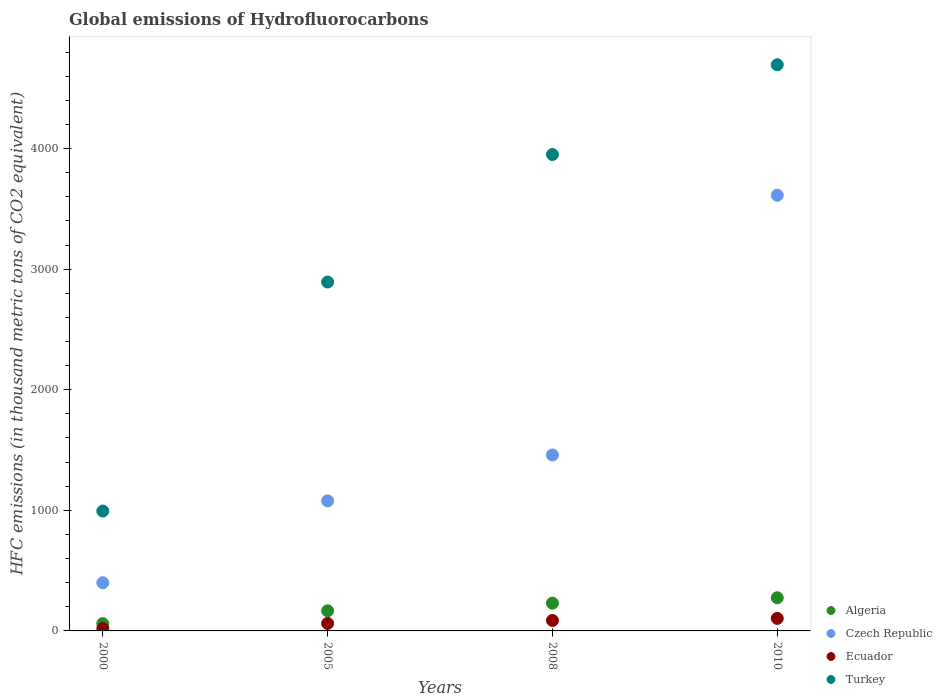How many different coloured dotlines are there?
Provide a succinct answer. 4. What is the global emissions of Hydrofluorocarbons in Algeria in 2000?
Provide a short and direct response. 60.5. Across all years, what is the maximum global emissions of Hydrofluorocarbons in Czech Republic?
Make the answer very short. 3613. Across all years, what is the minimum global emissions of Hydrofluorocarbons in Algeria?
Make the answer very short. 60.5. In which year was the global emissions of Hydrofluorocarbons in Ecuador maximum?
Your answer should be very brief. 2010. What is the total global emissions of Hydrofluorocarbons in Czech Republic in the graph?
Your answer should be compact. 6550.2. What is the difference between the global emissions of Hydrofluorocarbons in Algeria in 2005 and that in 2010?
Offer a terse response. -108.2. What is the difference between the global emissions of Hydrofluorocarbons in Turkey in 2000 and the global emissions of Hydrofluorocarbons in Algeria in 2005?
Your answer should be very brief. 827.6. What is the average global emissions of Hydrofluorocarbons in Ecuador per year?
Ensure brevity in your answer.  68.15. In the year 2008, what is the difference between the global emissions of Hydrofluorocarbons in Czech Republic and global emissions of Hydrofluorocarbons in Algeria?
Provide a succinct answer. 1228.8. In how many years, is the global emissions of Hydrofluorocarbons in Turkey greater than 2000 thousand metric tons?
Make the answer very short. 3. What is the ratio of the global emissions of Hydrofluorocarbons in Turkey in 2000 to that in 2008?
Keep it short and to the point. 0.25. Is the global emissions of Hydrofluorocarbons in Algeria in 2005 less than that in 2010?
Offer a very short reply. Yes. Is the difference between the global emissions of Hydrofluorocarbons in Czech Republic in 2005 and 2010 greater than the difference between the global emissions of Hydrofluorocarbons in Algeria in 2005 and 2010?
Your answer should be very brief. No. What is the difference between the highest and the second highest global emissions of Hydrofluorocarbons in Czech Republic?
Your response must be concise. 2154. What is the difference between the highest and the lowest global emissions of Hydrofluorocarbons in Czech Republic?
Your answer should be compact. 3213.5. In how many years, is the global emissions of Hydrofluorocarbons in Algeria greater than the average global emissions of Hydrofluorocarbons in Algeria taken over all years?
Your response must be concise. 2. Is the sum of the global emissions of Hydrofluorocarbons in Turkey in 2005 and 2010 greater than the maximum global emissions of Hydrofluorocarbons in Algeria across all years?
Give a very brief answer. Yes. Is it the case that in every year, the sum of the global emissions of Hydrofluorocarbons in Turkey and global emissions of Hydrofluorocarbons in Algeria  is greater than the sum of global emissions of Hydrofluorocarbons in Czech Republic and global emissions of Hydrofluorocarbons in Ecuador?
Keep it short and to the point. Yes. Is it the case that in every year, the sum of the global emissions of Hydrofluorocarbons in Turkey and global emissions of Hydrofluorocarbons in Czech Republic  is greater than the global emissions of Hydrofluorocarbons in Algeria?
Your answer should be compact. Yes. Does the global emissions of Hydrofluorocarbons in Czech Republic monotonically increase over the years?
Offer a terse response. Yes. How many dotlines are there?
Keep it short and to the point. 4. How many years are there in the graph?
Your response must be concise. 4. Does the graph contain any zero values?
Give a very brief answer. No. How are the legend labels stacked?
Provide a short and direct response. Vertical. What is the title of the graph?
Your response must be concise. Global emissions of Hydrofluorocarbons. What is the label or title of the X-axis?
Offer a terse response. Years. What is the label or title of the Y-axis?
Offer a very short reply. HFC emissions (in thousand metric tons of CO2 equivalent). What is the HFC emissions (in thousand metric tons of CO2 equivalent) of Algeria in 2000?
Your answer should be very brief. 60.5. What is the HFC emissions (in thousand metric tons of CO2 equivalent) in Czech Republic in 2000?
Make the answer very short. 399.5. What is the HFC emissions (in thousand metric tons of CO2 equivalent) in Turkey in 2000?
Ensure brevity in your answer.  994.4. What is the HFC emissions (in thousand metric tons of CO2 equivalent) in Algeria in 2005?
Provide a short and direct response. 166.8. What is the HFC emissions (in thousand metric tons of CO2 equivalent) of Czech Republic in 2005?
Give a very brief answer. 1078.7. What is the HFC emissions (in thousand metric tons of CO2 equivalent) of Ecuador in 2005?
Make the answer very short. 62.2. What is the HFC emissions (in thousand metric tons of CO2 equivalent) in Turkey in 2005?
Your answer should be compact. 2893.2. What is the HFC emissions (in thousand metric tons of CO2 equivalent) of Algeria in 2008?
Offer a terse response. 230.2. What is the HFC emissions (in thousand metric tons of CO2 equivalent) of Czech Republic in 2008?
Offer a very short reply. 1459. What is the HFC emissions (in thousand metric tons of CO2 equivalent) in Ecuador in 2008?
Make the answer very short. 86.7. What is the HFC emissions (in thousand metric tons of CO2 equivalent) in Turkey in 2008?
Your answer should be very brief. 3950.8. What is the HFC emissions (in thousand metric tons of CO2 equivalent) in Algeria in 2010?
Your answer should be compact. 275. What is the HFC emissions (in thousand metric tons of CO2 equivalent) in Czech Republic in 2010?
Keep it short and to the point. 3613. What is the HFC emissions (in thousand metric tons of CO2 equivalent) of Ecuador in 2010?
Provide a succinct answer. 104. What is the HFC emissions (in thousand metric tons of CO2 equivalent) of Turkey in 2010?
Provide a short and direct response. 4695. Across all years, what is the maximum HFC emissions (in thousand metric tons of CO2 equivalent) of Algeria?
Offer a very short reply. 275. Across all years, what is the maximum HFC emissions (in thousand metric tons of CO2 equivalent) in Czech Republic?
Offer a very short reply. 3613. Across all years, what is the maximum HFC emissions (in thousand metric tons of CO2 equivalent) in Ecuador?
Make the answer very short. 104. Across all years, what is the maximum HFC emissions (in thousand metric tons of CO2 equivalent) of Turkey?
Your response must be concise. 4695. Across all years, what is the minimum HFC emissions (in thousand metric tons of CO2 equivalent) in Algeria?
Offer a very short reply. 60.5. Across all years, what is the minimum HFC emissions (in thousand metric tons of CO2 equivalent) in Czech Republic?
Provide a short and direct response. 399.5. Across all years, what is the minimum HFC emissions (in thousand metric tons of CO2 equivalent) in Ecuador?
Offer a terse response. 19.7. Across all years, what is the minimum HFC emissions (in thousand metric tons of CO2 equivalent) in Turkey?
Offer a terse response. 994.4. What is the total HFC emissions (in thousand metric tons of CO2 equivalent) in Algeria in the graph?
Your response must be concise. 732.5. What is the total HFC emissions (in thousand metric tons of CO2 equivalent) of Czech Republic in the graph?
Provide a short and direct response. 6550.2. What is the total HFC emissions (in thousand metric tons of CO2 equivalent) of Ecuador in the graph?
Provide a short and direct response. 272.6. What is the total HFC emissions (in thousand metric tons of CO2 equivalent) of Turkey in the graph?
Provide a short and direct response. 1.25e+04. What is the difference between the HFC emissions (in thousand metric tons of CO2 equivalent) in Algeria in 2000 and that in 2005?
Offer a very short reply. -106.3. What is the difference between the HFC emissions (in thousand metric tons of CO2 equivalent) of Czech Republic in 2000 and that in 2005?
Your response must be concise. -679.2. What is the difference between the HFC emissions (in thousand metric tons of CO2 equivalent) in Ecuador in 2000 and that in 2005?
Provide a short and direct response. -42.5. What is the difference between the HFC emissions (in thousand metric tons of CO2 equivalent) of Turkey in 2000 and that in 2005?
Ensure brevity in your answer.  -1898.8. What is the difference between the HFC emissions (in thousand metric tons of CO2 equivalent) in Algeria in 2000 and that in 2008?
Your response must be concise. -169.7. What is the difference between the HFC emissions (in thousand metric tons of CO2 equivalent) of Czech Republic in 2000 and that in 2008?
Provide a succinct answer. -1059.5. What is the difference between the HFC emissions (in thousand metric tons of CO2 equivalent) in Ecuador in 2000 and that in 2008?
Keep it short and to the point. -67. What is the difference between the HFC emissions (in thousand metric tons of CO2 equivalent) in Turkey in 2000 and that in 2008?
Ensure brevity in your answer.  -2956.4. What is the difference between the HFC emissions (in thousand metric tons of CO2 equivalent) in Algeria in 2000 and that in 2010?
Make the answer very short. -214.5. What is the difference between the HFC emissions (in thousand metric tons of CO2 equivalent) in Czech Republic in 2000 and that in 2010?
Make the answer very short. -3213.5. What is the difference between the HFC emissions (in thousand metric tons of CO2 equivalent) in Ecuador in 2000 and that in 2010?
Offer a very short reply. -84.3. What is the difference between the HFC emissions (in thousand metric tons of CO2 equivalent) of Turkey in 2000 and that in 2010?
Keep it short and to the point. -3700.6. What is the difference between the HFC emissions (in thousand metric tons of CO2 equivalent) of Algeria in 2005 and that in 2008?
Make the answer very short. -63.4. What is the difference between the HFC emissions (in thousand metric tons of CO2 equivalent) in Czech Republic in 2005 and that in 2008?
Provide a short and direct response. -380.3. What is the difference between the HFC emissions (in thousand metric tons of CO2 equivalent) of Ecuador in 2005 and that in 2008?
Offer a very short reply. -24.5. What is the difference between the HFC emissions (in thousand metric tons of CO2 equivalent) in Turkey in 2005 and that in 2008?
Give a very brief answer. -1057.6. What is the difference between the HFC emissions (in thousand metric tons of CO2 equivalent) in Algeria in 2005 and that in 2010?
Give a very brief answer. -108.2. What is the difference between the HFC emissions (in thousand metric tons of CO2 equivalent) in Czech Republic in 2005 and that in 2010?
Your answer should be very brief. -2534.3. What is the difference between the HFC emissions (in thousand metric tons of CO2 equivalent) of Ecuador in 2005 and that in 2010?
Offer a very short reply. -41.8. What is the difference between the HFC emissions (in thousand metric tons of CO2 equivalent) in Turkey in 2005 and that in 2010?
Offer a terse response. -1801.8. What is the difference between the HFC emissions (in thousand metric tons of CO2 equivalent) of Algeria in 2008 and that in 2010?
Your answer should be very brief. -44.8. What is the difference between the HFC emissions (in thousand metric tons of CO2 equivalent) in Czech Republic in 2008 and that in 2010?
Your answer should be very brief. -2154. What is the difference between the HFC emissions (in thousand metric tons of CO2 equivalent) of Ecuador in 2008 and that in 2010?
Provide a succinct answer. -17.3. What is the difference between the HFC emissions (in thousand metric tons of CO2 equivalent) of Turkey in 2008 and that in 2010?
Keep it short and to the point. -744.2. What is the difference between the HFC emissions (in thousand metric tons of CO2 equivalent) in Algeria in 2000 and the HFC emissions (in thousand metric tons of CO2 equivalent) in Czech Republic in 2005?
Provide a succinct answer. -1018.2. What is the difference between the HFC emissions (in thousand metric tons of CO2 equivalent) of Algeria in 2000 and the HFC emissions (in thousand metric tons of CO2 equivalent) of Turkey in 2005?
Ensure brevity in your answer.  -2832.7. What is the difference between the HFC emissions (in thousand metric tons of CO2 equivalent) in Czech Republic in 2000 and the HFC emissions (in thousand metric tons of CO2 equivalent) in Ecuador in 2005?
Offer a very short reply. 337.3. What is the difference between the HFC emissions (in thousand metric tons of CO2 equivalent) in Czech Republic in 2000 and the HFC emissions (in thousand metric tons of CO2 equivalent) in Turkey in 2005?
Provide a succinct answer. -2493.7. What is the difference between the HFC emissions (in thousand metric tons of CO2 equivalent) of Ecuador in 2000 and the HFC emissions (in thousand metric tons of CO2 equivalent) of Turkey in 2005?
Your answer should be very brief. -2873.5. What is the difference between the HFC emissions (in thousand metric tons of CO2 equivalent) in Algeria in 2000 and the HFC emissions (in thousand metric tons of CO2 equivalent) in Czech Republic in 2008?
Your response must be concise. -1398.5. What is the difference between the HFC emissions (in thousand metric tons of CO2 equivalent) of Algeria in 2000 and the HFC emissions (in thousand metric tons of CO2 equivalent) of Ecuador in 2008?
Ensure brevity in your answer.  -26.2. What is the difference between the HFC emissions (in thousand metric tons of CO2 equivalent) of Algeria in 2000 and the HFC emissions (in thousand metric tons of CO2 equivalent) of Turkey in 2008?
Give a very brief answer. -3890.3. What is the difference between the HFC emissions (in thousand metric tons of CO2 equivalent) in Czech Republic in 2000 and the HFC emissions (in thousand metric tons of CO2 equivalent) in Ecuador in 2008?
Ensure brevity in your answer.  312.8. What is the difference between the HFC emissions (in thousand metric tons of CO2 equivalent) of Czech Republic in 2000 and the HFC emissions (in thousand metric tons of CO2 equivalent) of Turkey in 2008?
Offer a terse response. -3551.3. What is the difference between the HFC emissions (in thousand metric tons of CO2 equivalent) in Ecuador in 2000 and the HFC emissions (in thousand metric tons of CO2 equivalent) in Turkey in 2008?
Offer a terse response. -3931.1. What is the difference between the HFC emissions (in thousand metric tons of CO2 equivalent) in Algeria in 2000 and the HFC emissions (in thousand metric tons of CO2 equivalent) in Czech Republic in 2010?
Your answer should be compact. -3552.5. What is the difference between the HFC emissions (in thousand metric tons of CO2 equivalent) of Algeria in 2000 and the HFC emissions (in thousand metric tons of CO2 equivalent) of Ecuador in 2010?
Ensure brevity in your answer.  -43.5. What is the difference between the HFC emissions (in thousand metric tons of CO2 equivalent) of Algeria in 2000 and the HFC emissions (in thousand metric tons of CO2 equivalent) of Turkey in 2010?
Your response must be concise. -4634.5. What is the difference between the HFC emissions (in thousand metric tons of CO2 equivalent) in Czech Republic in 2000 and the HFC emissions (in thousand metric tons of CO2 equivalent) in Ecuador in 2010?
Provide a succinct answer. 295.5. What is the difference between the HFC emissions (in thousand metric tons of CO2 equivalent) of Czech Republic in 2000 and the HFC emissions (in thousand metric tons of CO2 equivalent) of Turkey in 2010?
Make the answer very short. -4295.5. What is the difference between the HFC emissions (in thousand metric tons of CO2 equivalent) of Ecuador in 2000 and the HFC emissions (in thousand metric tons of CO2 equivalent) of Turkey in 2010?
Your answer should be compact. -4675.3. What is the difference between the HFC emissions (in thousand metric tons of CO2 equivalent) of Algeria in 2005 and the HFC emissions (in thousand metric tons of CO2 equivalent) of Czech Republic in 2008?
Make the answer very short. -1292.2. What is the difference between the HFC emissions (in thousand metric tons of CO2 equivalent) of Algeria in 2005 and the HFC emissions (in thousand metric tons of CO2 equivalent) of Ecuador in 2008?
Your response must be concise. 80.1. What is the difference between the HFC emissions (in thousand metric tons of CO2 equivalent) of Algeria in 2005 and the HFC emissions (in thousand metric tons of CO2 equivalent) of Turkey in 2008?
Your response must be concise. -3784. What is the difference between the HFC emissions (in thousand metric tons of CO2 equivalent) of Czech Republic in 2005 and the HFC emissions (in thousand metric tons of CO2 equivalent) of Ecuador in 2008?
Give a very brief answer. 992. What is the difference between the HFC emissions (in thousand metric tons of CO2 equivalent) in Czech Republic in 2005 and the HFC emissions (in thousand metric tons of CO2 equivalent) in Turkey in 2008?
Your answer should be compact. -2872.1. What is the difference between the HFC emissions (in thousand metric tons of CO2 equivalent) in Ecuador in 2005 and the HFC emissions (in thousand metric tons of CO2 equivalent) in Turkey in 2008?
Ensure brevity in your answer.  -3888.6. What is the difference between the HFC emissions (in thousand metric tons of CO2 equivalent) of Algeria in 2005 and the HFC emissions (in thousand metric tons of CO2 equivalent) of Czech Republic in 2010?
Provide a succinct answer. -3446.2. What is the difference between the HFC emissions (in thousand metric tons of CO2 equivalent) in Algeria in 2005 and the HFC emissions (in thousand metric tons of CO2 equivalent) in Ecuador in 2010?
Your answer should be compact. 62.8. What is the difference between the HFC emissions (in thousand metric tons of CO2 equivalent) of Algeria in 2005 and the HFC emissions (in thousand metric tons of CO2 equivalent) of Turkey in 2010?
Your response must be concise. -4528.2. What is the difference between the HFC emissions (in thousand metric tons of CO2 equivalent) of Czech Republic in 2005 and the HFC emissions (in thousand metric tons of CO2 equivalent) of Ecuador in 2010?
Provide a short and direct response. 974.7. What is the difference between the HFC emissions (in thousand metric tons of CO2 equivalent) in Czech Republic in 2005 and the HFC emissions (in thousand metric tons of CO2 equivalent) in Turkey in 2010?
Provide a short and direct response. -3616.3. What is the difference between the HFC emissions (in thousand metric tons of CO2 equivalent) in Ecuador in 2005 and the HFC emissions (in thousand metric tons of CO2 equivalent) in Turkey in 2010?
Offer a terse response. -4632.8. What is the difference between the HFC emissions (in thousand metric tons of CO2 equivalent) in Algeria in 2008 and the HFC emissions (in thousand metric tons of CO2 equivalent) in Czech Republic in 2010?
Your answer should be very brief. -3382.8. What is the difference between the HFC emissions (in thousand metric tons of CO2 equivalent) of Algeria in 2008 and the HFC emissions (in thousand metric tons of CO2 equivalent) of Ecuador in 2010?
Make the answer very short. 126.2. What is the difference between the HFC emissions (in thousand metric tons of CO2 equivalent) of Algeria in 2008 and the HFC emissions (in thousand metric tons of CO2 equivalent) of Turkey in 2010?
Your response must be concise. -4464.8. What is the difference between the HFC emissions (in thousand metric tons of CO2 equivalent) in Czech Republic in 2008 and the HFC emissions (in thousand metric tons of CO2 equivalent) in Ecuador in 2010?
Your answer should be compact. 1355. What is the difference between the HFC emissions (in thousand metric tons of CO2 equivalent) of Czech Republic in 2008 and the HFC emissions (in thousand metric tons of CO2 equivalent) of Turkey in 2010?
Your answer should be very brief. -3236. What is the difference between the HFC emissions (in thousand metric tons of CO2 equivalent) in Ecuador in 2008 and the HFC emissions (in thousand metric tons of CO2 equivalent) in Turkey in 2010?
Ensure brevity in your answer.  -4608.3. What is the average HFC emissions (in thousand metric tons of CO2 equivalent) of Algeria per year?
Offer a terse response. 183.12. What is the average HFC emissions (in thousand metric tons of CO2 equivalent) in Czech Republic per year?
Your answer should be compact. 1637.55. What is the average HFC emissions (in thousand metric tons of CO2 equivalent) of Ecuador per year?
Offer a very short reply. 68.15. What is the average HFC emissions (in thousand metric tons of CO2 equivalent) in Turkey per year?
Give a very brief answer. 3133.35. In the year 2000, what is the difference between the HFC emissions (in thousand metric tons of CO2 equivalent) of Algeria and HFC emissions (in thousand metric tons of CO2 equivalent) of Czech Republic?
Your answer should be very brief. -339. In the year 2000, what is the difference between the HFC emissions (in thousand metric tons of CO2 equivalent) in Algeria and HFC emissions (in thousand metric tons of CO2 equivalent) in Ecuador?
Offer a very short reply. 40.8. In the year 2000, what is the difference between the HFC emissions (in thousand metric tons of CO2 equivalent) in Algeria and HFC emissions (in thousand metric tons of CO2 equivalent) in Turkey?
Your answer should be very brief. -933.9. In the year 2000, what is the difference between the HFC emissions (in thousand metric tons of CO2 equivalent) in Czech Republic and HFC emissions (in thousand metric tons of CO2 equivalent) in Ecuador?
Your response must be concise. 379.8. In the year 2000, what is the difference between the HFC emissions (in thousand metric tons of CO2 equivalent) in Czech Republic and HFC emissions (in thousand metric tons of CO2 equivalent) in Turkey?
Offer a terse response. -594.9. In the year 2000, what is the difference between the HFC emissions (in thousand metric tons of CO2 equivalent) in Ecuador and HFC emissions (in thousand metric tons of CO2 equivalent) in Turkey?
Ensure brevity in your answer.  -974.7. In the year 2005, what is the difference between the HFC emissions (in thousand metric tons of CO2 equivalent) of Algeria and HFC emissions (in thousand metric tons of CO2 equivalent) of Czech Republic?
Give a very brief answer. -911.9. In the year 2005, what is the difference between the HFC emissions (in thousand metric tons of CO2 equivalent) in Algeria and HFC emissions (in thousand metric tons of CO2 equivalent) in Ecuador?
Make the answer very short. 104.6. In the year 2005, what is the difference between the HFC emissions (in thousand metric tons of CO2 equivalent) of Algeria and HFC emissions (in thousand metric tons of CO2 equivalent) of Turkey?
Offer a terse response. -2726.4. In the year 2005, what is the difference between the HFC emissions (in thousand metric tons of CO2 equivalent) of Czech Republic and HFC emissions (in thousand metric tons of CO2 equivalent) of Ecuador?
Your answer should be compact. 1016.5. In the year 2005, what is the difference between the HFC emissions (in thousand metric tons of CO2 equivalent) of Czech Republic and HFC emissions (in thousand metric tons of CO2 equivalent) of Turkey?
Give a very brief answer. -1814.5. In the year 2005, what is the difference between the HFC emissions (in thousand metric tons of CO2 equivalent) in Ecuador and HFC emissions (in thousand metric tons of CO2 equivalent) in Turkey?
Make the answer very short. -2831. In the year 2008, what is the difference between the HFC emissions (in thousand metric tons of CO2 equivalent) in Algeria and HFC emissions (in thousand metric tons of CO2 equivalent) in Czech Republic?
Ensure brevity in your answer.  -1228.8. In the year 2008, what is the difference between the HFC emissions (in thousand metric tons of CO2 equivalent) of Algeria and HFC emissions (in thousand metric tons of CO2 equivalent) of Ecuador?
Provide a succinct answer. 143.5. In the year 2008, what is the difference between the HFC emissions (in thousand metric tons of CO2 equivalent) in Algeria and HFC emissions (in thousand metric tons of CO2 equivalent) in Turkey?
Offer a very short reply. -3720.6. In the year 2008, what is the difference between the HFC emissions (in thousand metric tons of CO2 equivalent) in Czech Republic and HFC emissions (in thousand metric tons of CO2 equivalent) in Ecuador?
Offer a terse response. 1372.3. In the year 2008, what is the difference between the HFC emissions (in thousand metric tons of CO2 equivalent) of Czech Republic and HFC emissions (in thousand metric tons of CO2 equivalent) of Turkey?
Your answer should be compact. -2491.8. In the year 2008, what is the difference between the HFC emissions (in thousand metric tons of CO2 equivalent) in Ecuador and HFC emissions (in thousand metric tons of CO2 equivalent) in Turkey?
Offer a terse response. -3864.1. In the year 2010, what is the difference between the HFC emissions (in thousand metric tons of CO2 equivalent) in Algeria and HFC emissions (in thousand metric tons of CO2 equivalent) in Czech Republic?
Offer a terse response. -3338. In the year 2010, what is the difference between the HFC emissions (in thousand metric tons of CO2 equivalent) in Algeria and HFC emissions (in thousand metric tons of CO2 equivalent) in Ecuador?
Your answer should be compact. 171. In the year 2010, what is the difference between the HFC emissions (in thousand metric tons of CO2 equivalent) in Algeria and HFC emissions (in thousand metric tons of CO2 equivalent) in Turkey?
Your answer should be compact. -4420. In the year 2010, what is the difference between the HFC emissions (in thousand metric tons of CO2 equivalent) of Czech Republic and HFC emissions (in thousand metric tons of CO2 equivalent) of Ecuador?
Your response must be concise. 3509. In the year 2010, what is the difference between the HFC emissions (in thousand metric tons of CO2 equivalent) of Czech Republic and HFC emissions (in thousand metric tons of CO2 equivalent) of Turkey?
Your answer should be compact. -1082. In the year 2010, what is the difference between the HFC emissions (in thousand metric tons of CO2 equivalent) in Ecuador and HFC emissions (in thousand metric tons of CO2 equivalent) in Turkey?
Offer a terse response. -4591. What is the ratio of the HFC emissions (in thousand metric tons of CO2 equivalent) of Algeria in 2000 to that in 2005?
Your answer should be compact. 0.36. What is the ratio of the HFC emissions (in thousand metric tons of CO2 equivalent) in Czech Republic in 2000 to that in 2005?
Offer a very short reply. 0.37. What is the ratio of the HFC emissions (in thousand metric tons of CO2 equivalent) in Ecuador in 2000 to that in 2005?
Your answer should be very brief. 0.32. What is the ratio of the HFC emissions (in thousand metric tons of CO2 equivalent) of Turkey in 2000 to that in 2005?
Make the answer very short. 0.34. What is the ratio of the HFC emissions (in thousand metric tons of CO2 equivalent) in Algeria in 2000 to that in 2008?
Provide a succinct answer. 0.26. What is the ratio of the HFC emissions (in thousand metric tons of CO2 equivalent) in Czech Republic in 2000 to that in 2008?
Give a very brief answer. 0.27. What is the ratio of the HFC emissions (in thousand metric tons of CO2 equivalent) of Ecuador in 2000 to that in 2008?
Keep it short and to the point. 0.23. What is the ratio of the HFC emissions (in thousand metric tons of CO2 equivalent) of Turkey in 2000 to that in 2008?
Make the answer very short. 0.25. What is the ratio of the HFC emissions (in thousand metric tons of CO2 equivalent) of Algeria in 2000 to that in 2010?
Make the answer very short. 0.22. What is the ratio of the HFC emissions (in thousand metric tons of CO2 equivalent) of Czech Republic in 2000 to that in 2010?
Provide a short and direct response. 0.11. What is the ratio of the HFC emissions (in thousand metric tons of CO2 equivalent) in Ecuador in 2000 to that in 2010?
Your answer should be very brief. 0.19. What is the ratio of the HFC emissions (in thousand metric tons of CO2 equivalent) in Turkey in 2000 to that in 2010?
Provide a short and direct response. 0.21. What is the ratio of the HFC emissions (in thousand metric tons of CO2 equivalent) of Algeria in 2005 to that in 2008?
Make the answer very short. 0.72. What is the ratio of the HFC emissions (in thousand metric tons of CO2 equivalent) in Czech Republic in 2005 to that in 2008?
Make the answer very short. 0.74. What is the ratio of the HFC emissions (in thousand metric tons of CO2 equivalent) in Ecuador in 2005 to that in 2008?
Your response must be concise. 0.72. What is the ratio of the HFC emissions (in thousand metric tons of CO2 equivalent) in Turkey in 2005 to that in 2008?
Keep it short and to the point. 0.73. What is the ratio of the HFC emissions (in thousand metric tons of CO2 equivalent) of Algeria in 2005 to that in 2010?
Your answer should be compact. 0.61. What is the ratio of the HFC emissions (in thousand metric tons of CO2 equivalent) of Czech Republic in 2005 to that in 2010?
Your answer should be very brief. 0.3. What is the ratio of the HFC emissions (in thousand metric tons of CO2 equivalent) in Ecuador in 2005 to that in 2010?
Provide a short and direct response. 0.6. What is the ratio of the HFC emissions (in thousand metric tons of CO2 equivalent) of Turkey in 2005 to that in 2010?
Your answer should be very brief. 0.62. What is the ratio of the HFC emissions (in thousand metric tons of CO2 equivalent) of Algeria in 2008 to that in 2010?
Your answer should be compact. 0.84. What is the ratio of the HFC emissions (in thousand metric tons of CO2 equivalent) of Czech Republic in 2008 to that in 2010?
Offer a terse response. 0.4. What is the ratio of the HFC emissions (in thousand metric tons of CO2 equivalent) of Ecuador in 2008 to that in 2010?
Your answer should be compact. 0.83. What is the ratio of the HFC emissions (in thousand metric tons of CO2 equivalent) of Turkey in 2008 to that in 2010?
Ensure brevity in your answer.  0.84. What is the difference between the highest and the second highest HFC emissions (in thousand metric tons of CO2 equivalent) of Algeria?
Provide a short and direct response. 44.8. What is the difference between the highest and the second highest HFC emissions (in thousand metric tons of CO2 equivalent) of Czech Republic?
Your answer should be very brief. 2154. What is the difference between the highest and the second highest HFC emissions (in thousand metric tons of CO2 equivalent) in Turkey?
Offer a very short reply. 744.2. What is the difference between the highest and the lowest HFC emissions (in thousand metric tons of CO2 equivalent) of Algeria?
Keep it short and to the point. 214.5. What is the difference between the highest and the lowest HFC emissions (in thousand metric tons of CO2 equivalent) of Czech Republic?
Provide a succinct answer. 3213.5. What is the difference between the highest and the lowest HFC emissions (in thousand metric tons of CO2 equivalent) in Ecuador?
Offer a very short reply. 84.3. What is the difference between the highest and the lowest HFC emissions (in thousand metric tons of CO2 equivalent) of Turkey?
Your response must be concise. 3700.6. 